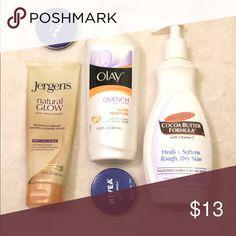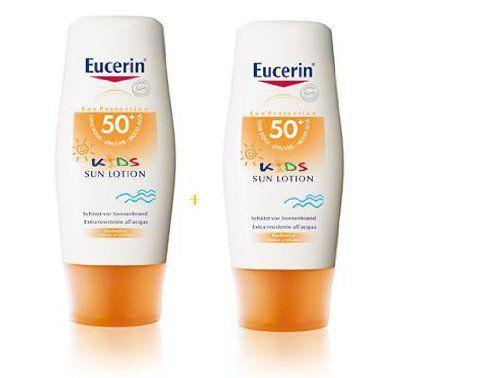The first image is the image on the left, the second image is the image on the right. Considering the images on both sides, is "Each image shows one sunscreen product standing to the right of the box the product is packaged in to be sold." valid? Answer yes or no. No. The first image is the image on the left, the second image is the image on the right. For the images shown, is this caption "Each image shows one skincare product next to its box." true? Answer yes or no. No. 